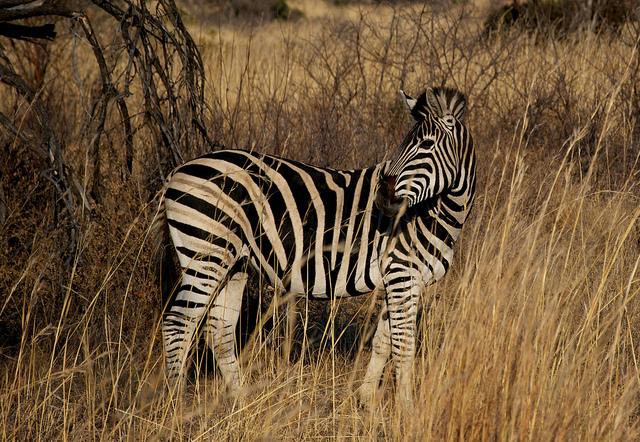What kind of animal is this?
Quick response, please. Zebra. Is this zebra's mane striped?
Keep it brief. Yes. Is the grass taller than the zebra?
Quick response, please. Yes. How many zebras?
Keep it brief. 1. Where are the animals looking?
Answer briefly. Left. How many zebras are in the photo?
Answer briefly. 1. 